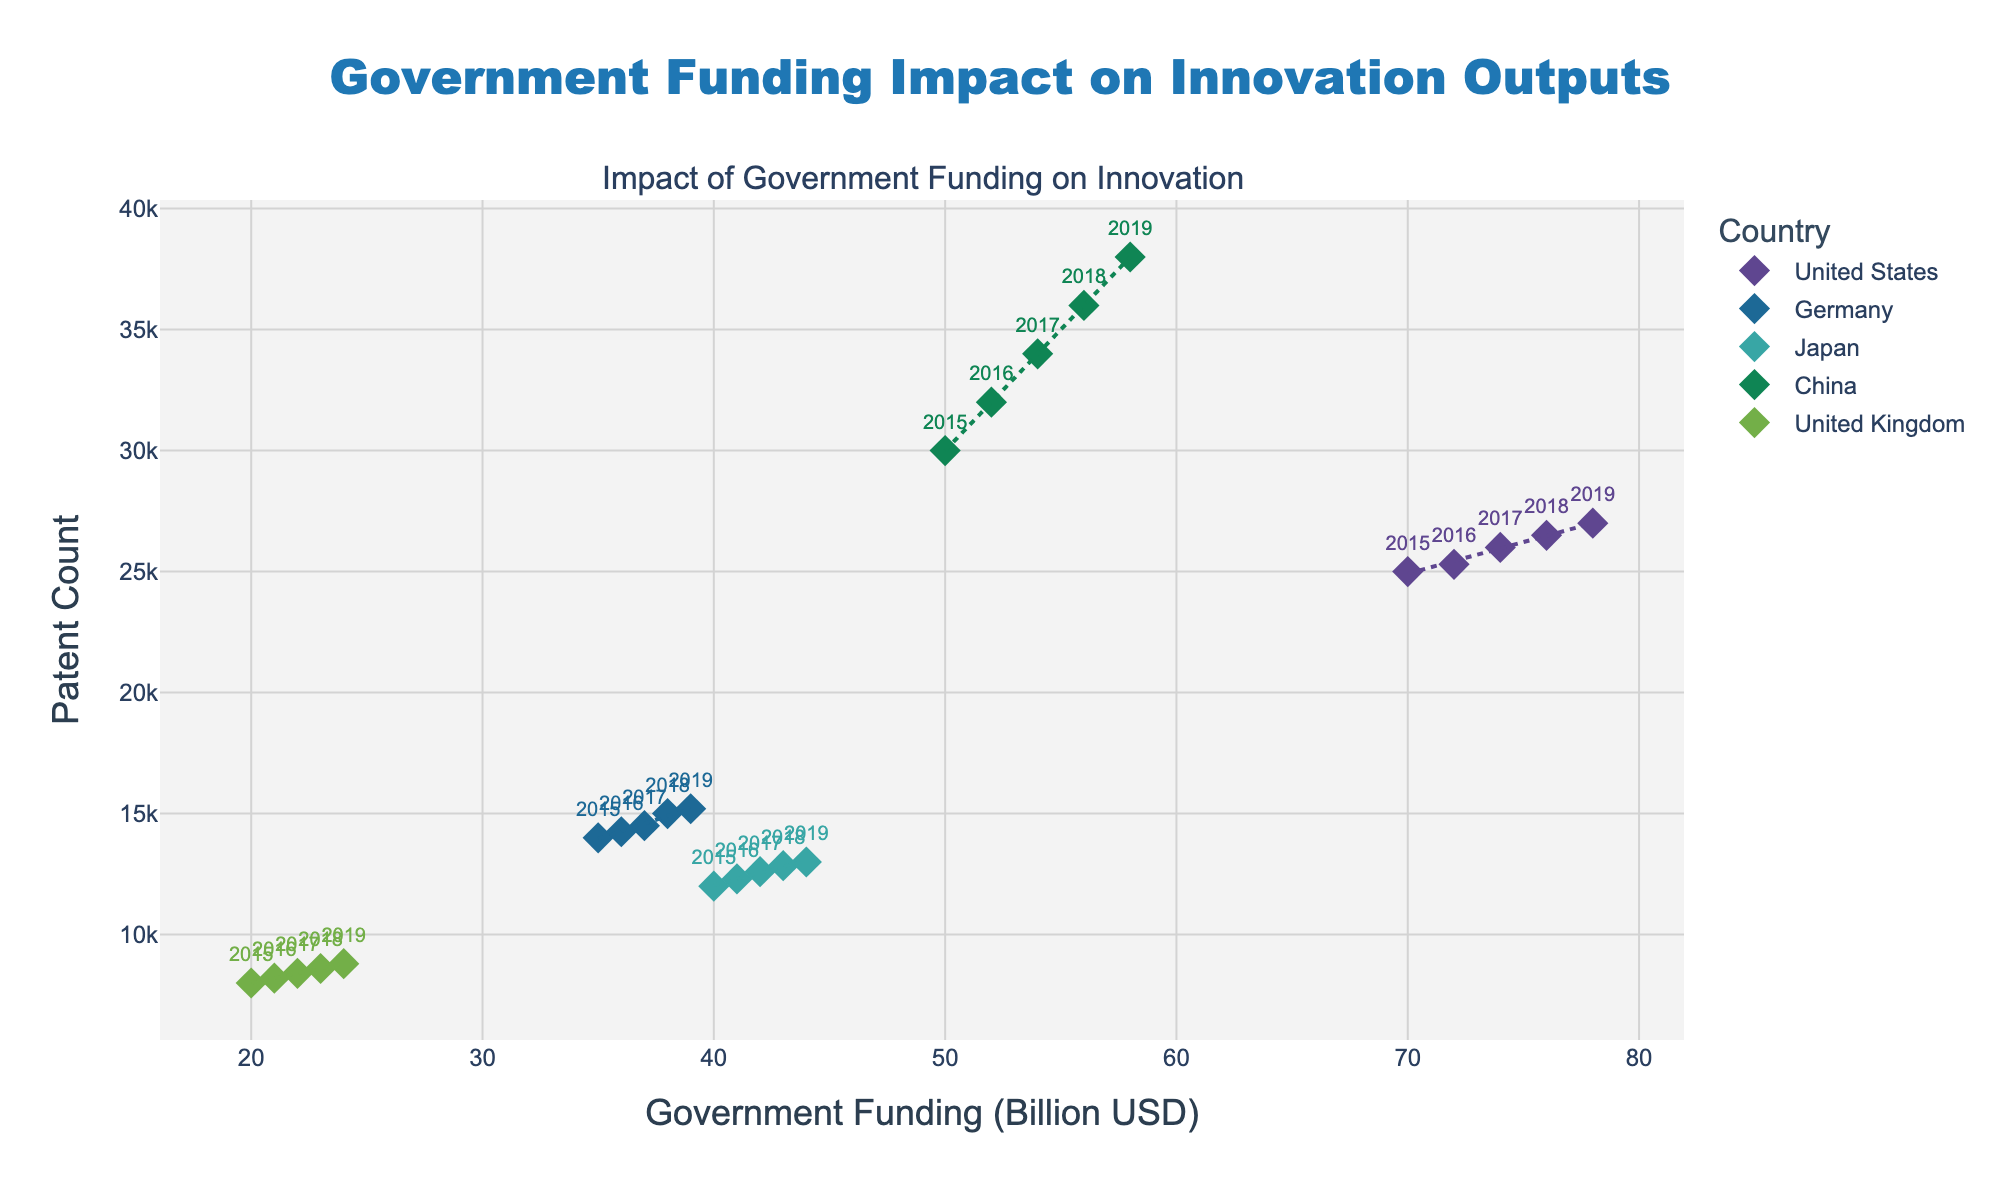How many countries are represented in the figure? The figure depicts one scatter plot where different points and trend lines are color-coded. Each color corresponds to a different country. By counting the unique colors or names in the legend, we can determine the number of countries.
Answer: 5 Which country has the highest government funding in 2019? To determine which country has the highest government funding, we look at the x-coordinates for the year 2019. The country with the highest value on the x-axis for 2019 will have received the most funding.
Answer: United States What is the general trend of patent counts when government funding increases in China? The general trend can be seen by looking at the trend line for China. If the line has an upward slope, it indicates that patent counts increase with higher government funding.
Answer: Increasing For which country does government funding have the weakest impact on patent counts? To find this, we need to compare the slopes of the trend lines for each country. The country with the flattest trend line has the weakest impact.
Answer: United Kingdom How does the United States' patent count in 2019 compare to Germany's in the same year? To compare the patent counts for the United States and Germany in 2019, we look at the y-values for the year 2019 for each country and identify which is higher.
Answer: United States has more patents What is the patent count for Japan in 2017, and how does it compare to China in the same year? Look at the y-values for Japan and China in 2017. Compare these two values to determine which is higher.
Answer: Japan: 12600, China: 34000. China has more patents What is the overall trend of government funding and patent count for the United Kingdom over the years? To determine the overall trend, observe the scatter plot points and the trend line for the United Kingdom. The trend line shows if there's an overall increase or decrease in patent counts with government funding over the years.
Answer: Increasing Which country shows the most significant increase in patent count from 2015 to 2019? To find this, look at the scatter plot for each country, find the patent counts for the years 2015 and 2019, and calculate the difference. The country with the highest increase is the answer.
Answer: China Is there any country where government funding decreases over the years, and what is the impact on the patent count? First, observe the x-coordinates for each country over the years to check for any decrease in government funding. Then look at the corresponding y-coordinates (patent counts) to see the impact.
Answer: No, all countries show an increase in government funding How do the trends differ between developed and developing countries in terms of government funding and innovation outputs? Compare the slopes of the trend lines and the scatter plot points for developed countries (such as the United States, Germany, Japan, United Kingdom) and a developing country (China). The differences in steepness and direction of these trend lines indicate differences in how government funding impacts innovation.
Answer: Developed countries show steady increase; China shows a larger increase 